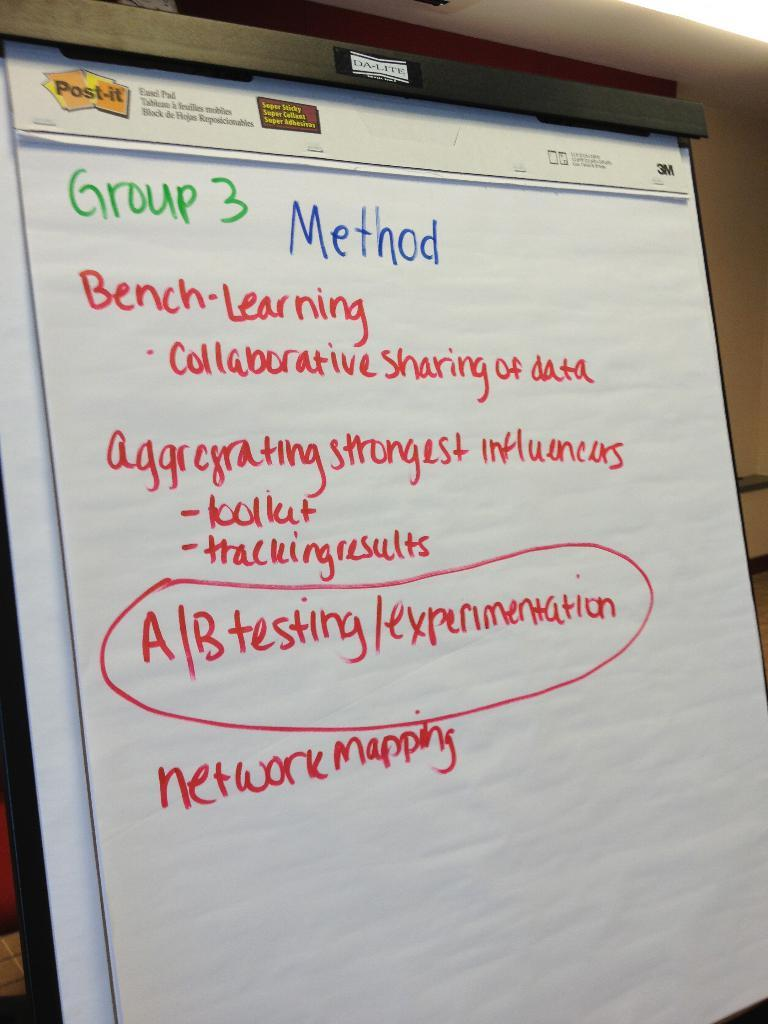<image>
Relay a brief, clear account of the picture shown. A large paper pad on an easel says Group 3 Method. 